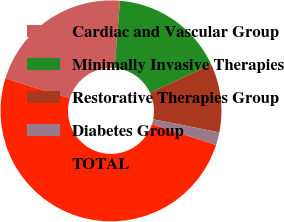Convert chart to OTSL. <chart><loc_0><loc_0><loc_500><loc_500><pie_chart><fcel>Cardiac and Vascular Group<fcel>Minimally Invasive Therapies<fcel>Restorative Therapies Group<fcel>Diabetes Group<fcel>TOTAL<nl><fcel>21.57%<fcel>16.79%<fcel>10.03%<fcel>1.88%<fcel>49.73%<nl></chart> 